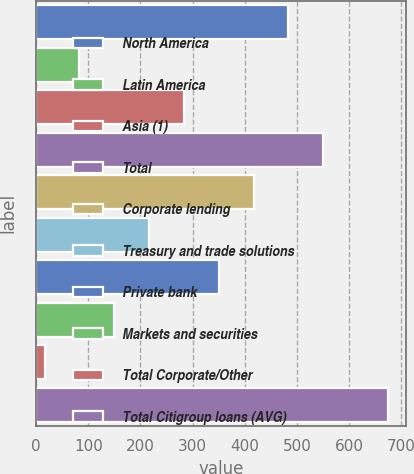<chart> <loc_0><loc_0><loc_500><loc_500><bar_chart><fcel>North America<fcel>Latin America<fcel>Asia (1)<fcel>Total<fcel>Corporate lending<fcel>Treasury and trade solutions<fcel>Private bank<fcel>Markets and securities<fcel>Total Corporate/Other<fcel>Total Citigroup loans (AVG)<nl><fcel>483.77<fcel>82.91<fcel>283.34<fcel>550.58<fcel>416.96<fcel>216.53<fcel>350.15<fcel>149.72<fcel>16.1<fcel>675.5<nl></chart> 